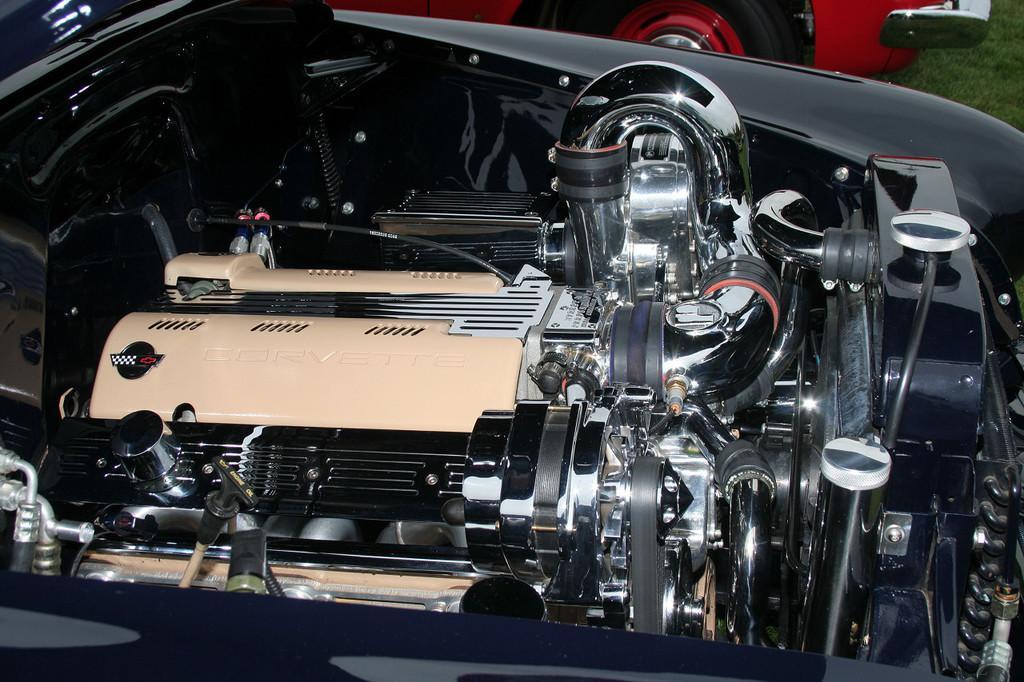Could you give a brief overview of what you see in this image? In this picture we can see vehicle parts. Here we can see grass and a vehicle which is truncated. 